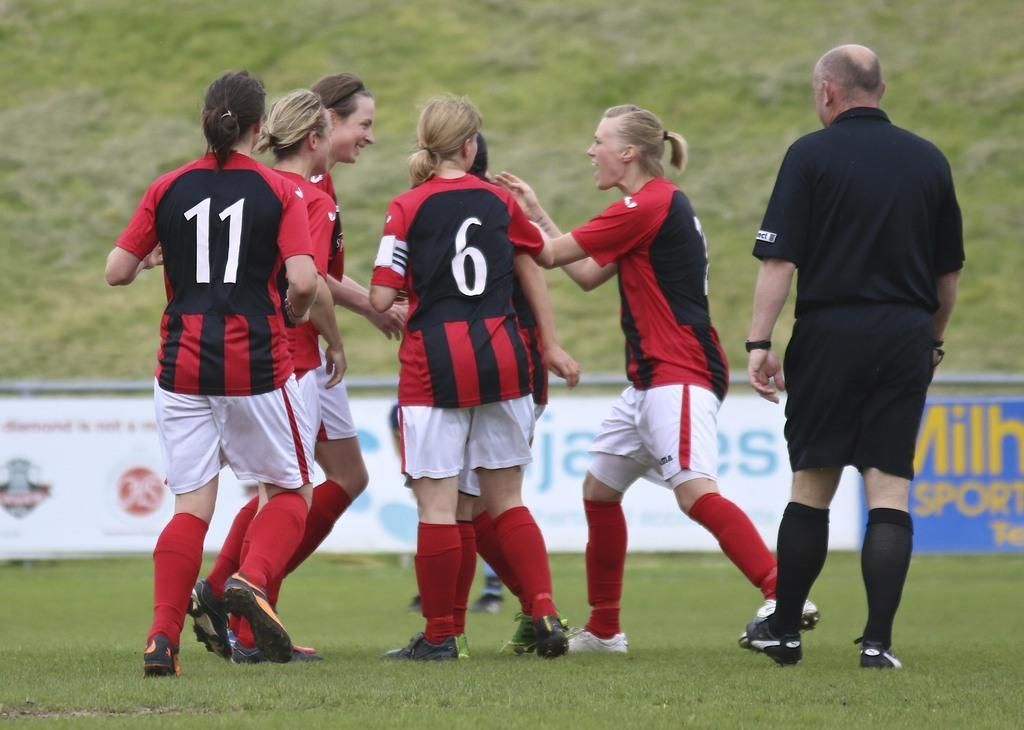<image>
Create a compact narrative representing the image presented. Woman wearing a number 11 jersey next to a girl wearing a number 6 jersey. 